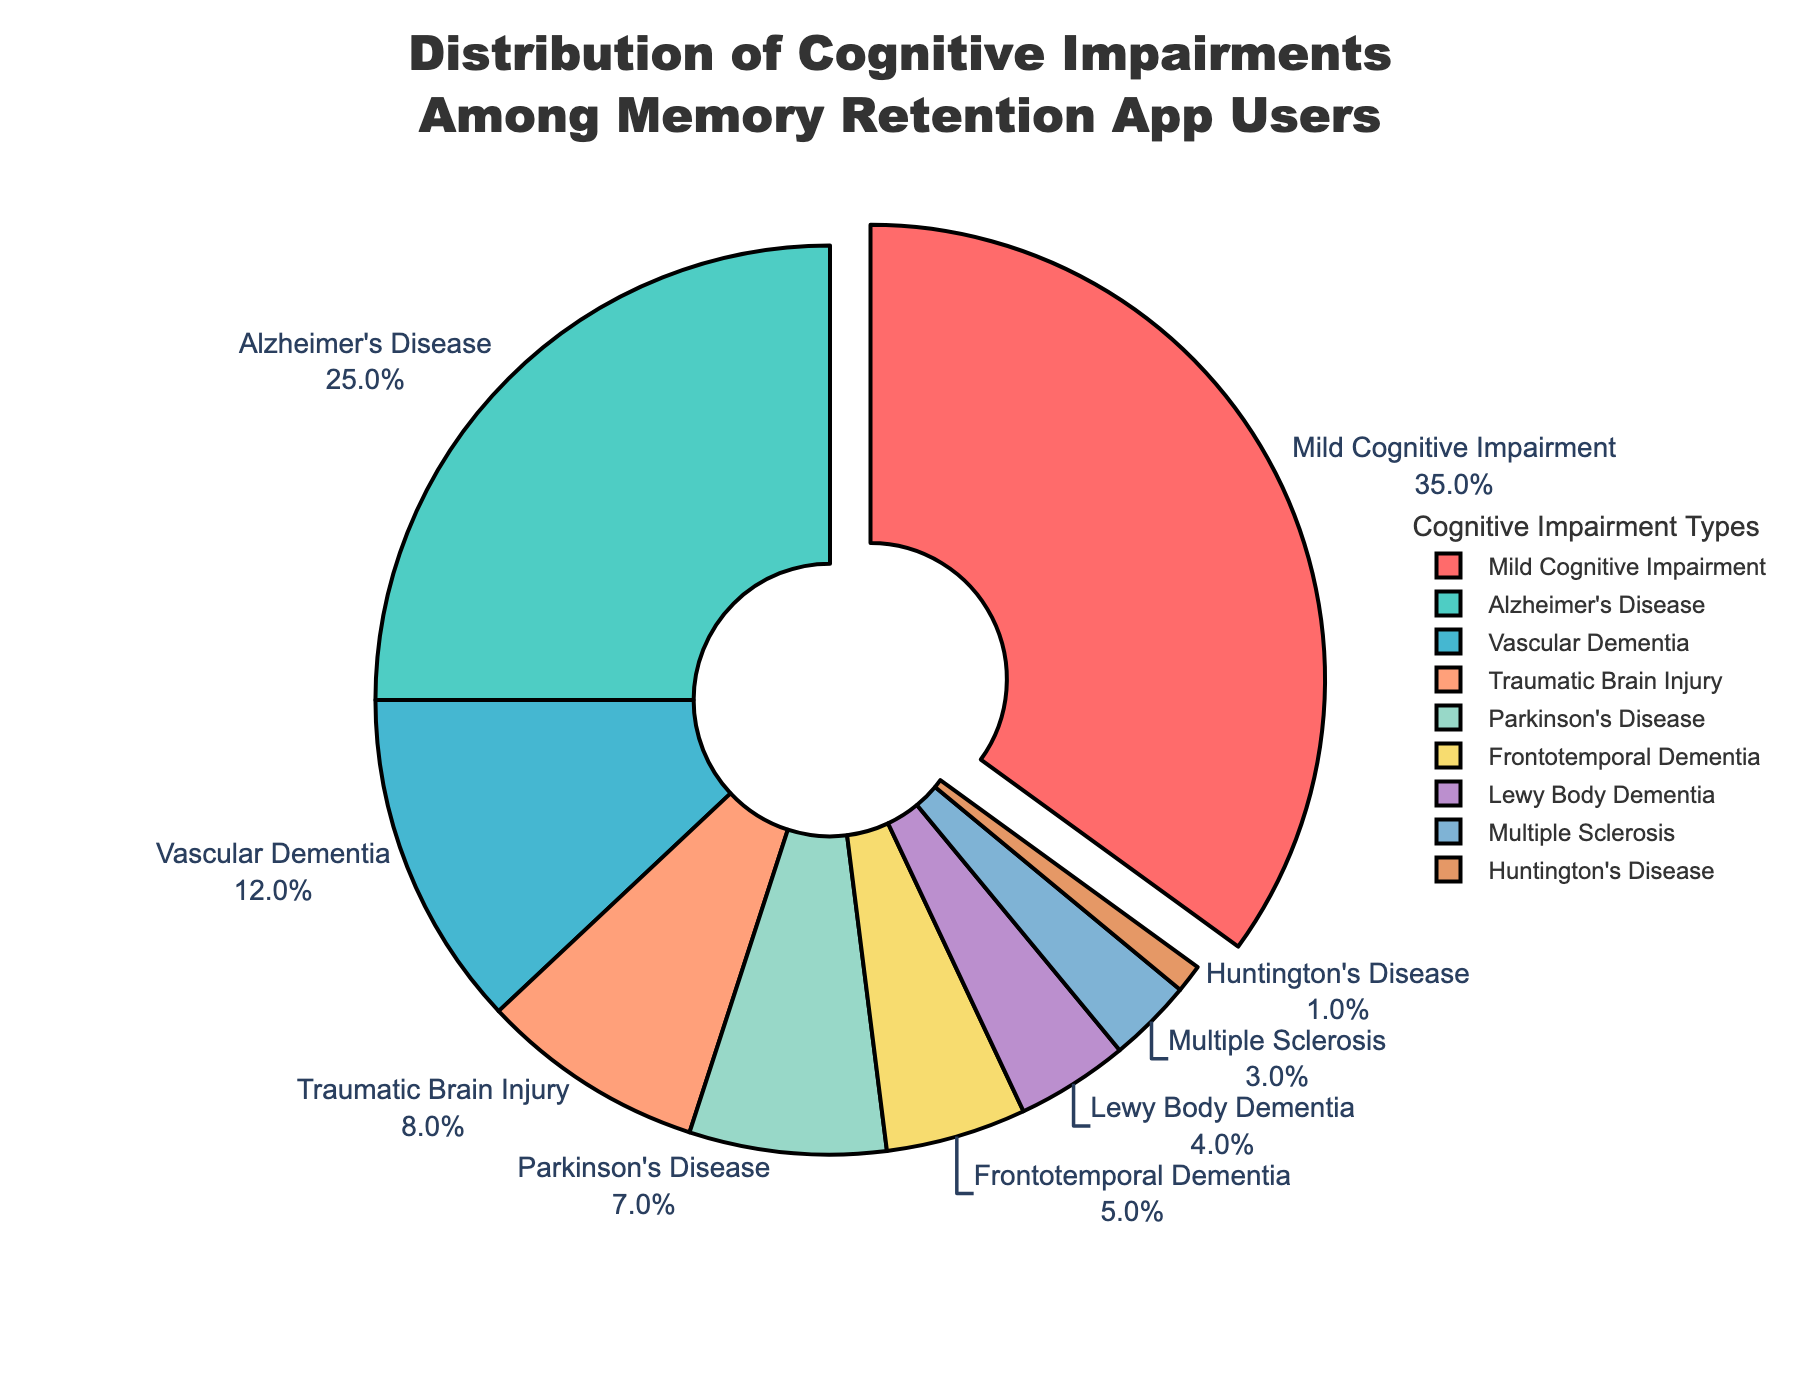what's the percentage of users with Alzheimer's Disease? Look for the segment labeled "Alzheimer's Disease" on the pie chart. The percentage is indicated beside the label.
Answer: 25% Which cognitive impairment type has the largest percentage of users? Identify the segment of the pie chart that is pulled out. Confirm the label and percentage associated with it. The pulled-out segment is labeled "Mild Cognitive Impairment".
Answer: Mild Cognitive Impairment Compare the proportions of users with Frontotemporal Dementia and Huntington's Disease. By how much does one exceed the other? Find the percentages for both "Frontotemporal Dementia" and "Huntington's Disease". Subtract the smaller percentage from the larger one: 5% - 1%.
Answer: 4% What is the combined percentage of users with Vascular Dementia and Parkinson's Disease? Find the percentages for both "Vascular Dementia" and "Parkinson's Disease". Add the two percentages together: 12% + 7%.
Answer: 19% Which cognitive impairment types have percentages less than 10%? Identify the segments with percentages less than 10%. These segments are "Traumatic Brain Injury", "Parkinson's Disease", "Frontotemporal Dementia", "Lewy Body Dementia", "Multiple Sclerosis", and "Huntington's Disease".
Answer: Traumatic Brain Injury, Parkinson's Disease, Frontotemporal Dementia, Lewy Body Dementia, Multiple Sclerosis, Huntington's Disease Identify the cognitive impairment type represented by the blue color. Look for the segment colored in blue. The label next to this segment indicates the cognitive impairment type as "Traumatic Brain Injury".
Answer: Traumatic Brain Injury Compare the total percentage of all other cognitive impairment types combined to the percentage of Mild Cognitive Impairment. Which is greater and by how much? Sum the percentages of all cognitive impairment types except "Mild Cognitive Impairment" (25 + 12 + 8 + 7 + 5 + 4 + 3 + 1 = 65%). Then, compare it with the percentage of "Mild Cognitive Impairment" (35%). The total for all other types is greater: 65% - 35%.
Answer: 30% What cognitive impairment types together represent approximately one quarter of the users? Identify the impairment types whose percentages sum up to approximately 25%. The percentages for "Parkinson's Disease" (7%), "Frontotemporal Dementia" (5%), "Lewy Body Dementia" (4%), "Multiple Sclerosis" (3%), and "Huntington's Disease" (1%) add up to 20%, which is close to a quarter.
Answer: Parkinson's Disease, Frontotemporal Dementia, Lewy Body Dementia, Multiple Sclerosis, Huntington's Disease If the total number of app users is 1000, how many users have Alzheimer's Disease? Calculate the number by using the percentage given: 25% of 1000 is 1000 * 0.25.
Answer: 250 users 